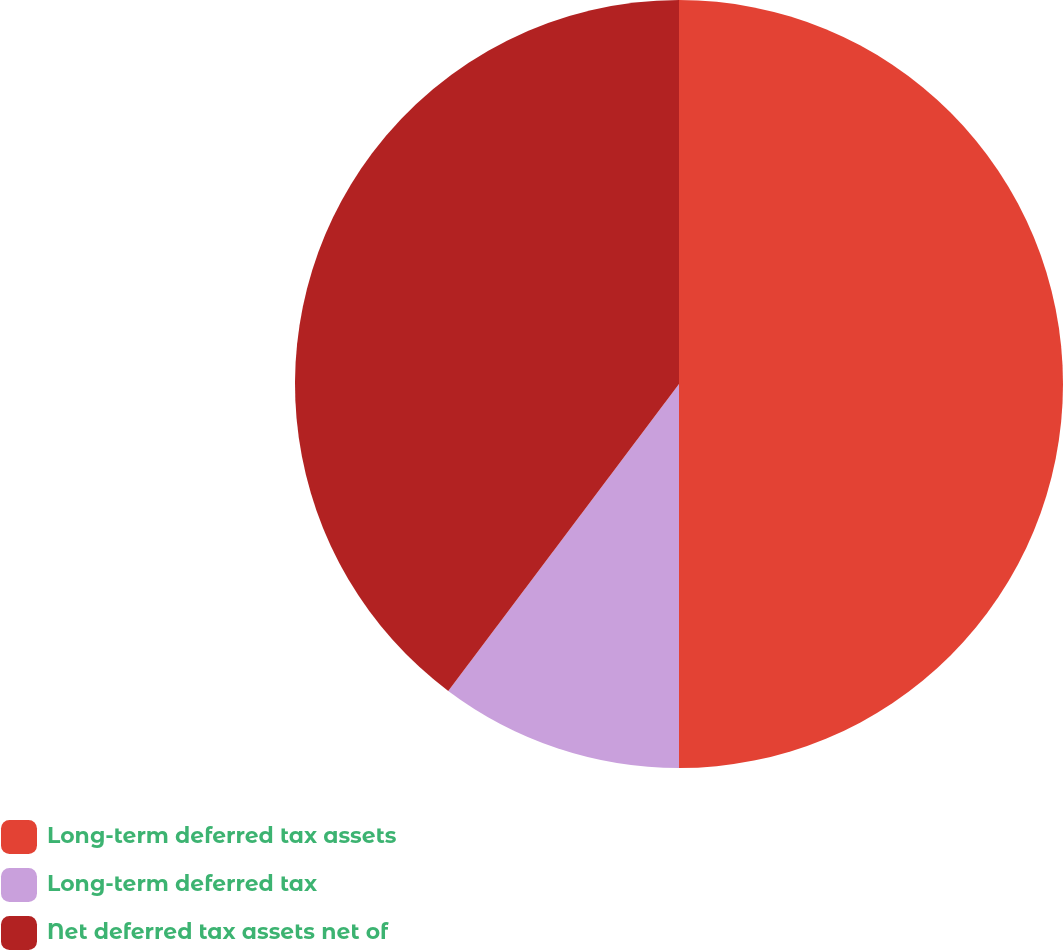Convert chart. <chart><loc_0><loc_0><loc_500><loc_500><pie_chart><fcel>Long-term deferred tax assets<fcel>Long-term deferred tax<fcel>Net deferred tax assets net of<nl><fcel>50.0%<fcel>10.26%<fcel>39.74%<nl></chart> 